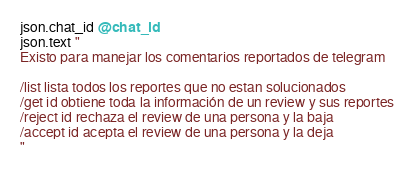Convert code to text. <code><loc_0><loc_0><loc_500><loc_500><_Ruby_>json.chat_id @chat_id
json.text "
Existo para manejar los comentarios reportados de telegram

/list lista todos los reportes que no estan solucionados
/get id obtiene toda la información de un review y sus reportes
/reject id rechaza el review de una persona y la baja
/accept id acepta el review de una persona y la deja
"
</code> 